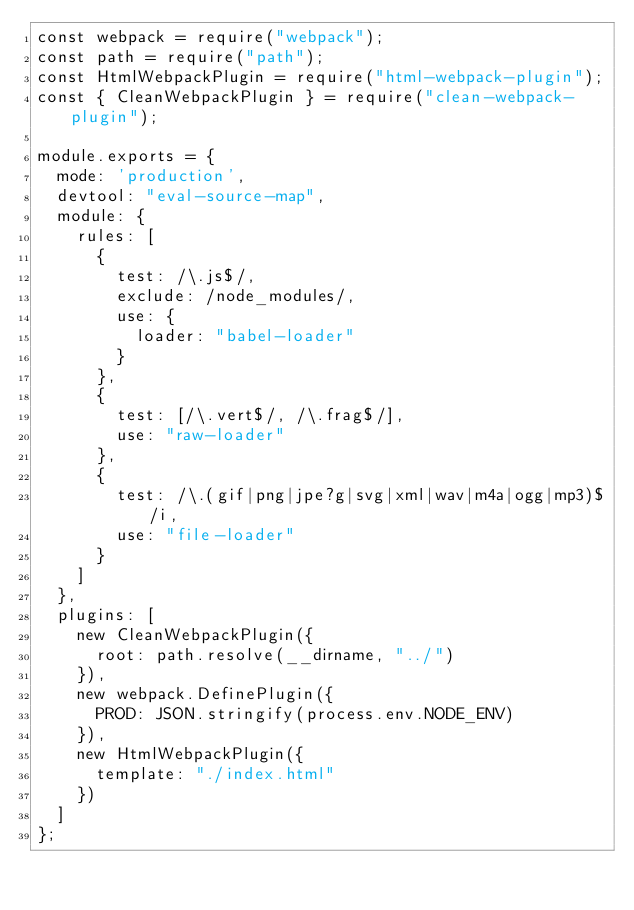<code> <loc_0><loc_0><loc_500><loc_500><_JavaScript_>const webpack = require("webpack");
const path = require("path");
const HtmlWebpackPlugin = require("html-webpack-plugin");
const { CleanWebpackPlugin } = require("clean-webpack-plugin");

module.exports = {
  mode: 'production',
  devtool: "eval-source-map",
  module: {
    rules: [
      {
        test: /\.js$/,
        exclude: /node_modules/,
        use: {
          loader: "babel-loader"
        }
      },
      {
        test: [/\.vert$/, /\.frag$/],
        use: "raw-loader"
      },
      {
        test: /\.(gif|png|jpe?g|svg|xml|wav|m4a|ogg|mp3)$/i,
        use: "file-loader"
      }
    ]
  },
  plugins: [
    new CleanWebpackPlugin({
      root: path.resolve(__dirname, "../")
    }),
    new webpack.DefinePlugin({
      PROD: JSON.stringify(process.env.NODE_ENV)
    }),
    new HtmlWebpackPlugin({
      template: "./index.html"
    })
  ]
};
</code> 